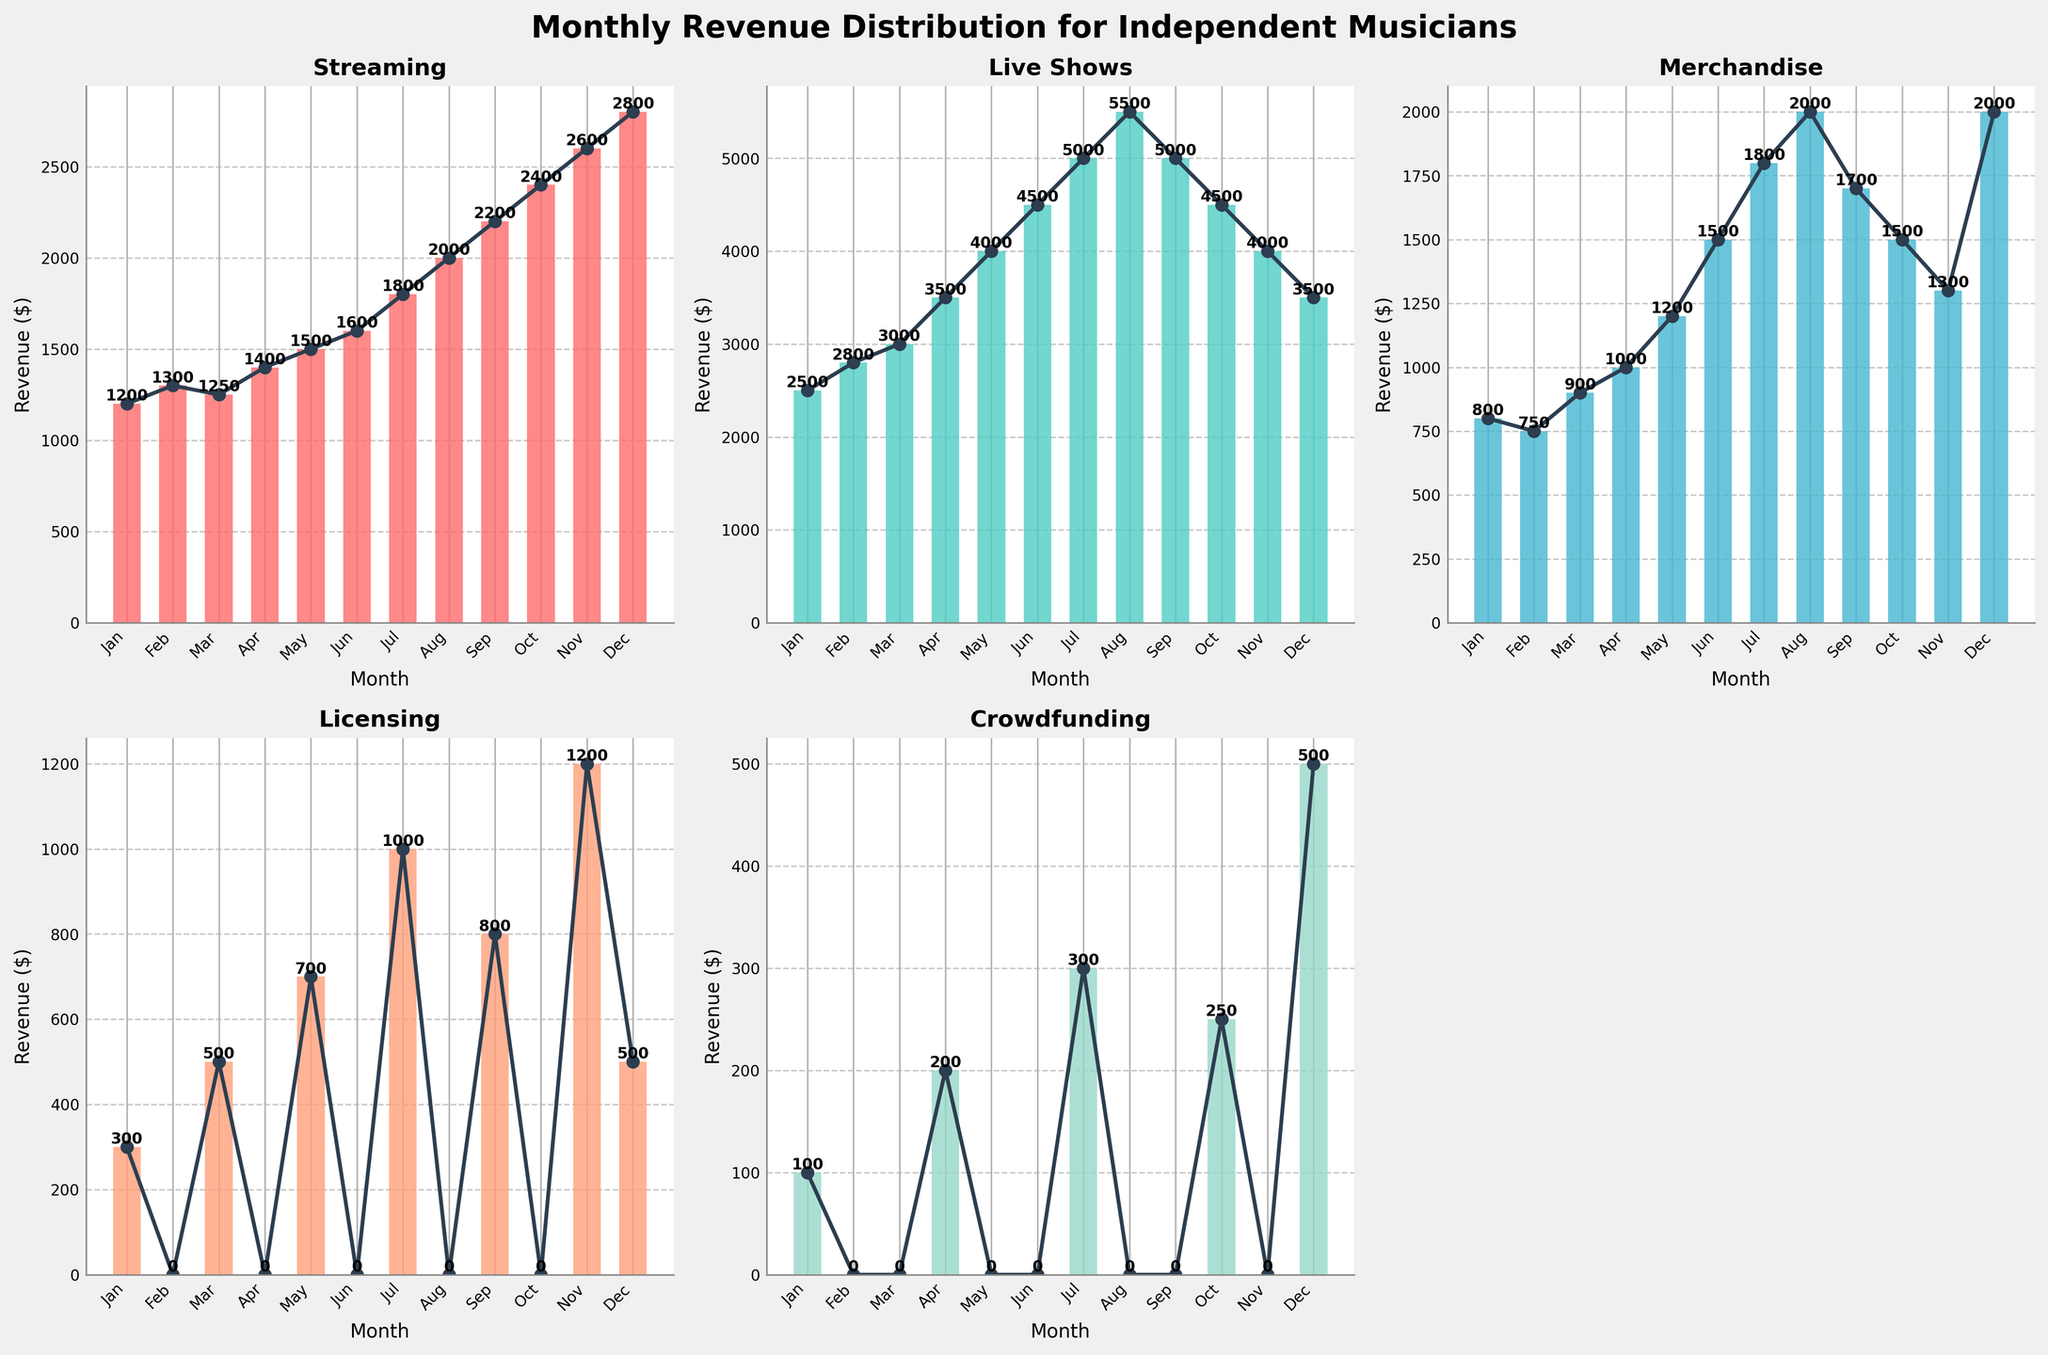Which month had the highest revenue from Live Shows? Look at the subplot for Live Shows and identify the tallest bar. The tallest bar represents August.
Answer: August What is the total revenue from Crowdfunding across all months? Sum up the Crowdfunding revenue for each month. The values are: 100 + 0 + 0 + 200 + 0 + 0 + 300 + 0 + 0 + 250 + 0 + 500 = 1350
Answer: 1350 In which month was the difference between Live Shows and Streaming revenue the smallest? Calculate the difference between Live Shows and Streaming revenue for each month and find the smallest difference. For January to December, the differences are: 1300, 1500, 1750, 2100, 2500, 2900, 3200, 3500, 2800, 2100, 1400, 700. The smallest difference is in December.
Answer: December Which revenue source had the steepest increase from May to June? Check the height of the bars for May and June across all subplots and identify the source with the biggest difference. Streaming increased by 100, Live Shows by 500, Merchandise by 300, Licensing had no revenue in June, and Crowdfunding had no revenue in both months. The steepest increase was in Live Shows.
Answer: Live Shows In which month did Licensing outperform Merchandise the most? Subtract Merchandise revenue from Licensing revenue for each month and look for the largest positive difference. Differences by month: -500, -750, -400, -1000, -1200, -1500, -800, -2000, -900, -1500, -100, -1500. The largest positive difference occurs in November with 1200 - 1300 = -100. However, in November, the value is positive as Licensing (1200) outperformed Merchandise (1300).
Answer: November 